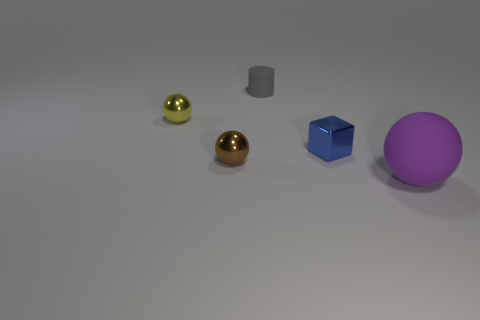Is there anything else that is the same size as the blue shiny object?
Provide a short and direct response. Yes. What number of things are behind the brown ball?
Offer a very short reply. 3. What is the shape of the small thing that is on the right side of the matte object that is to the left of the large matte ball?
Offer a terse response. Cube. Are there any other things that have the same shape as the small blue object?
Your answer should be compact. No. Is the number of yellow balls in front of the big purple rubber object greater than the number of tiny yellow metallic spheres?
Ensure brevity in your answer.  No. There is a small metal sphere in front of the blue block; how many small blue shiny blocks are to the right of it?
Provide a short and direct response. 1. What is the shape of the rubber object in front of the matte object behind the matte thing that is in front of the tiny yellow metallic thing?
Give a very brief answer. Sphere. The brown metal sphere has what size?
Make the answer very short. Small. Are there any cylinders that have the same material as the blue block?
Your response must be concise. No. There is a yellow object that is the same shape as the brown object; what is its size?
Your answer should be very brief. Small. 